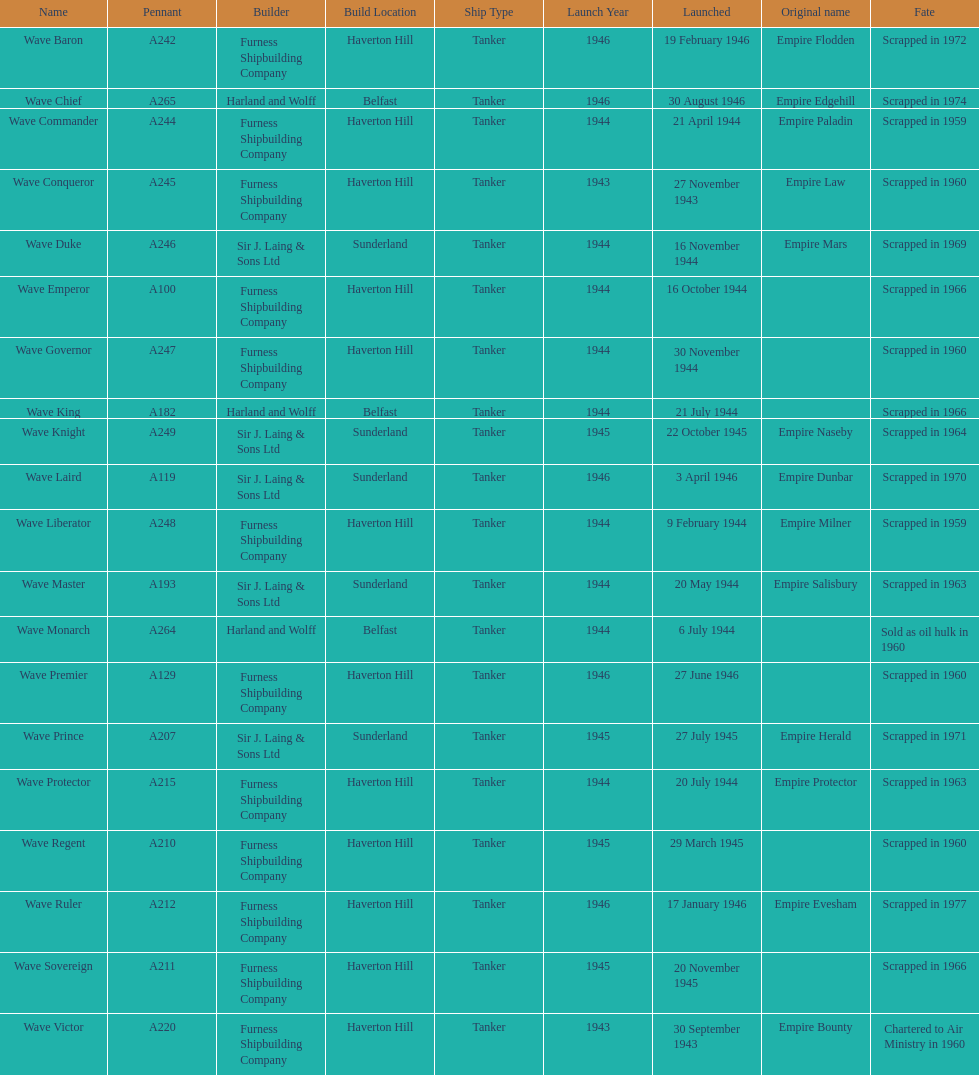How many ships were launched in the year 1944? 9. 